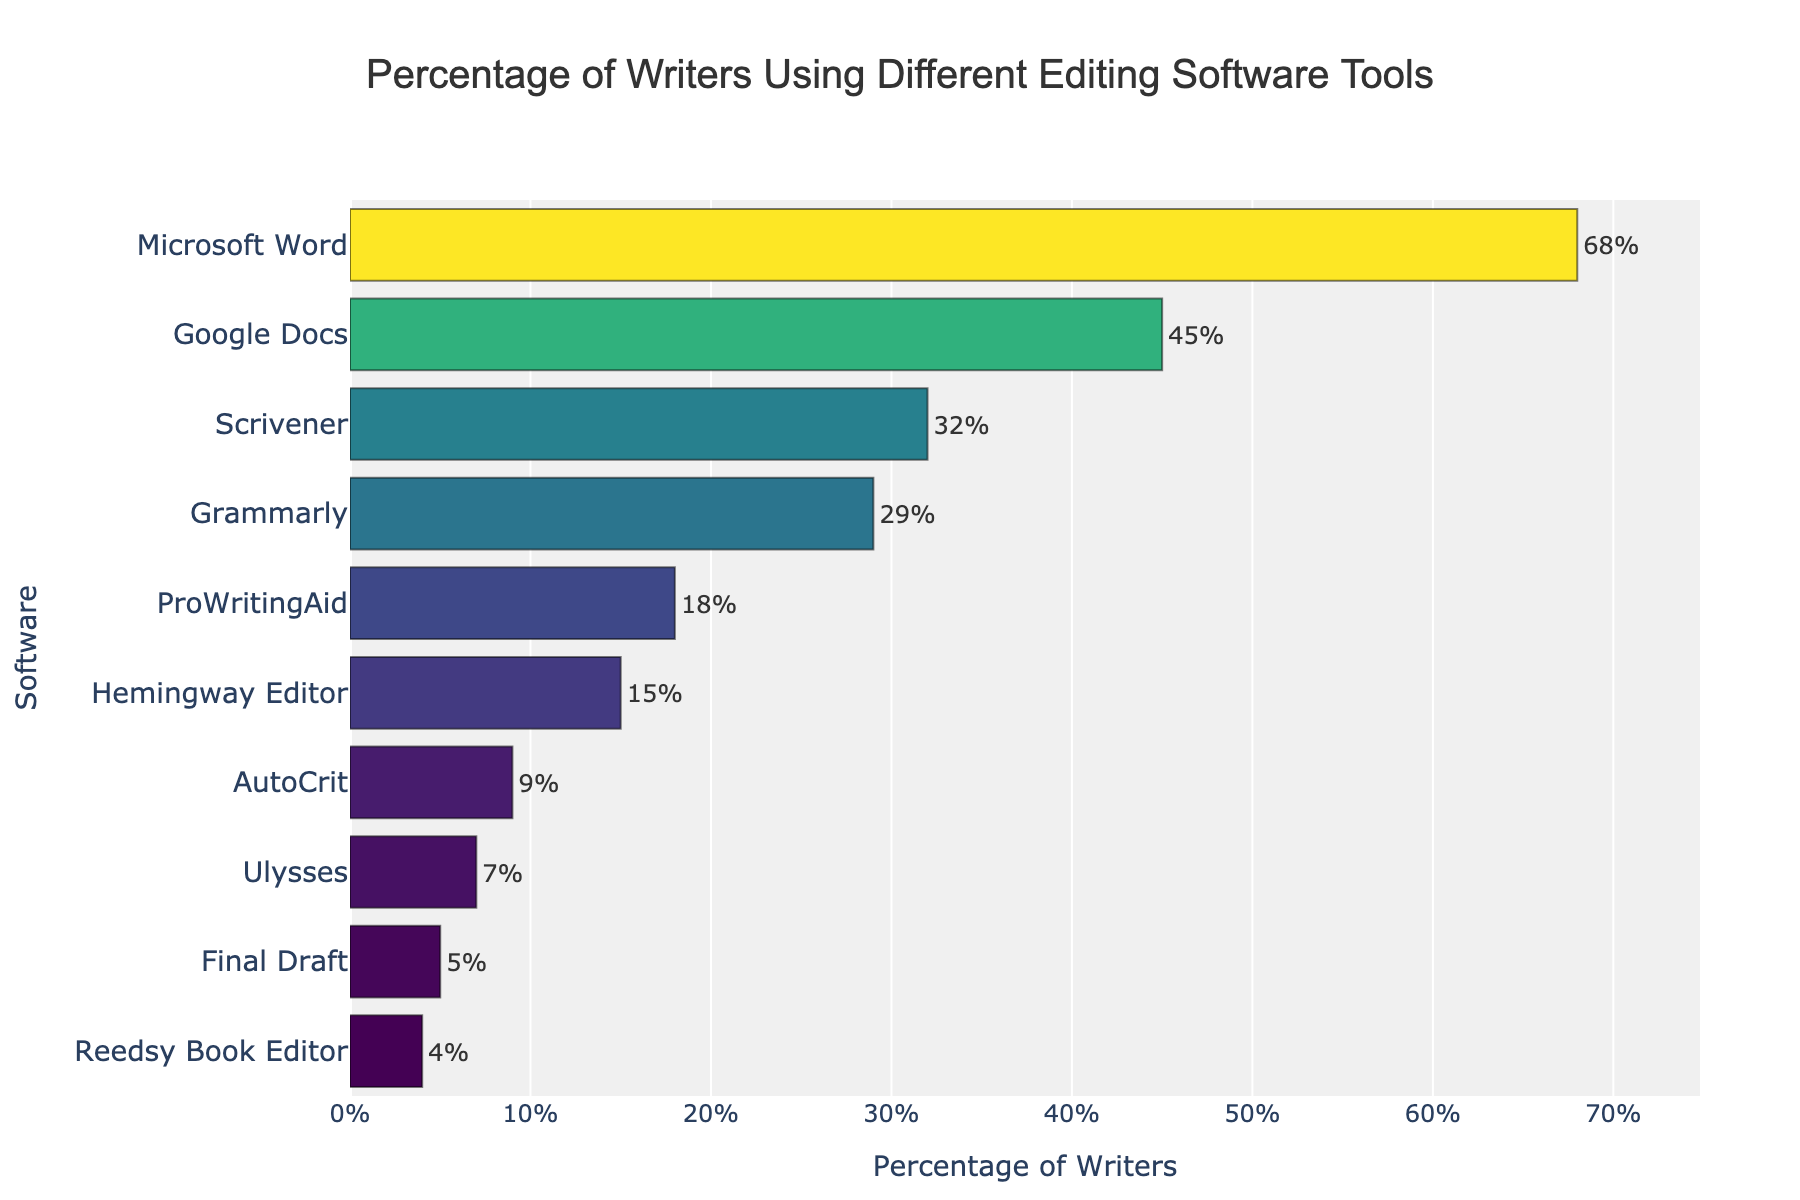Which editing software tool is used by the highest percentage of writers? The bar representing Microsoft Word is the longest, indicating it is used by the highest percentage of writers at 68%.
Answer: Microsoft Word Which editing software tool is used by the lowest percentage of writers? The bar for Reedsy Book Editor is the shortest, showing that it is used by only 4% of writers.
Answer: Reedsy Book Editor How many editing tools are used by at least 20% of writers? By examining the bars from the top, Microsoft Word, Google Docs, Scrivener, and Grammarly all have percentages above 20%. This totals to 4 tools.
Answer: 4 What is the difference in percentage of writers using Microsoft Word compared to Final Draft? Microsoft Word is used by 68% of writers, and Final Draft is used by 5%, so the difference is 68% - 5% = 63%.
Answer: 63% Which editing tool has a percentage that falls between 25% and 35%? Scrivener, with a percentage of 32%, falls within the range of 25% to 35%.
Answer: Scrivener Are there more writers using Google Docs or Grammarly? The bar for Google Docs is longer than the bar for Grammarly, indicating that 45% use Google Docs compared to 29% for Grammarly.
Answer: Google Docs What is the average percentage of writers using Microsoft Word, Google Docs, and Scrivener? Add the percentages for Microsoft Word (68%), Google Docs (45%), and Scrivener (32%), then divide by 3: (68 + 45 + 32) / 3 = 145 / 3 ≈ 48.33%.
Answer: 48.33% Which editing tool has a visual color most similar to ProWritingAid on the chart? The editing tool just below ProWritingAid is Hemingway Editor, and it shares a similar greenish color hue due to the similar percentage range (18% vs. 15%).
Answer: Hemingway Editor What is the combined percentage of writers using Hemingway Editor and Ulysses? Add the percentage of writers using Hemingway Editor (15%) and Ulysses (7%): 15% + 7% = 22%.
Answer: 22% Between AutoCrit and Reedsy Book Editor, which tool has a higher user percentage? The bar for AutoCrit is longer than that for Reedsy Book Editor, with AutoCrit at 9% and Reedsy Book Editor at 4%.
Answer: AutoCrit 